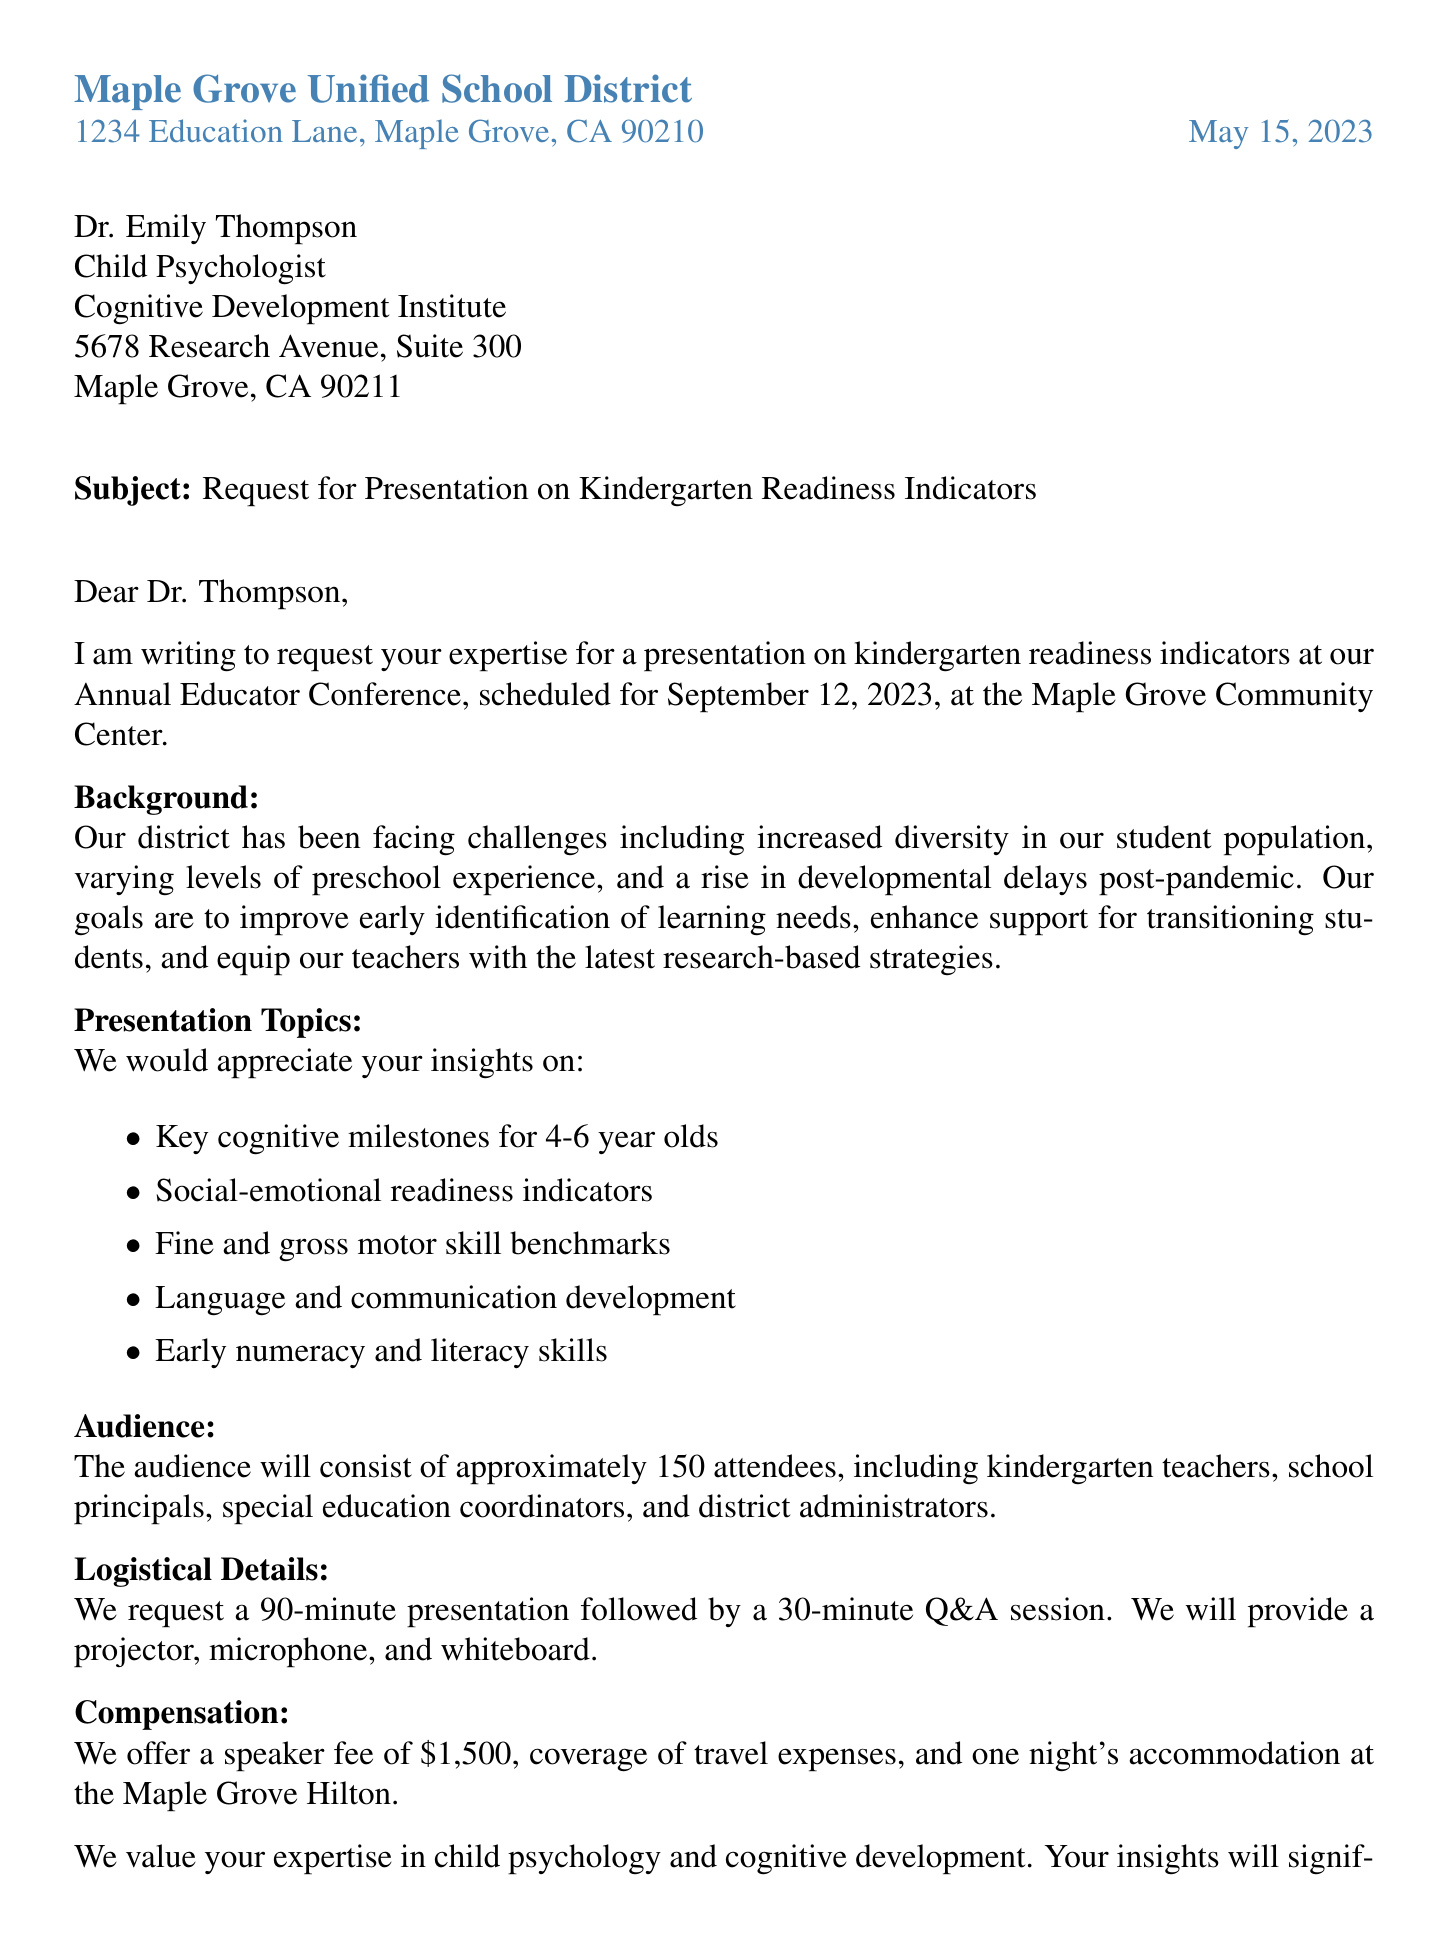What is the name of the school district? The school district is identified at the beginning of the letter.
Answer: Maple Grove Unified School District What is the date of the event? The date of the event is mentioned in the introduction section of the letter.
Answer: September 12, 2023 Who is the recipient of the letter? The recipient's details are provided right after the address of the school district.
Answer: Dr. Emily Thompson What is the speaker fee offered? The compensation section outlines the speaker fee for the presentation.
Answer: $1,500 How long is the presentation scheduled to last? The logistical details indicate the duration of the presentation.
Answer: 90 minutes What type of audience is expected at the presentation? The audience composition is mentioned in the audience information section.
Answer: Kindergarten teachers What are the subjects to be discussed in the presentation? The topics provided in the letter outline the areas of focus for the presentation.
Answer: Key cognitive milestones for 4-6 year olds What is the purpose of the letter? The introduction section specifies the main intention of the letter.
Answer: To request your expertise for a presentation When should the recipient confirm their availability? The closing remarks detail the deadline for the recipient's response.
Answer: June 1, 2023 What is the contact email provided in the letter? The contact information for the sender includes an email address.
Answer: sjohnson@maplegroveusd.edu 